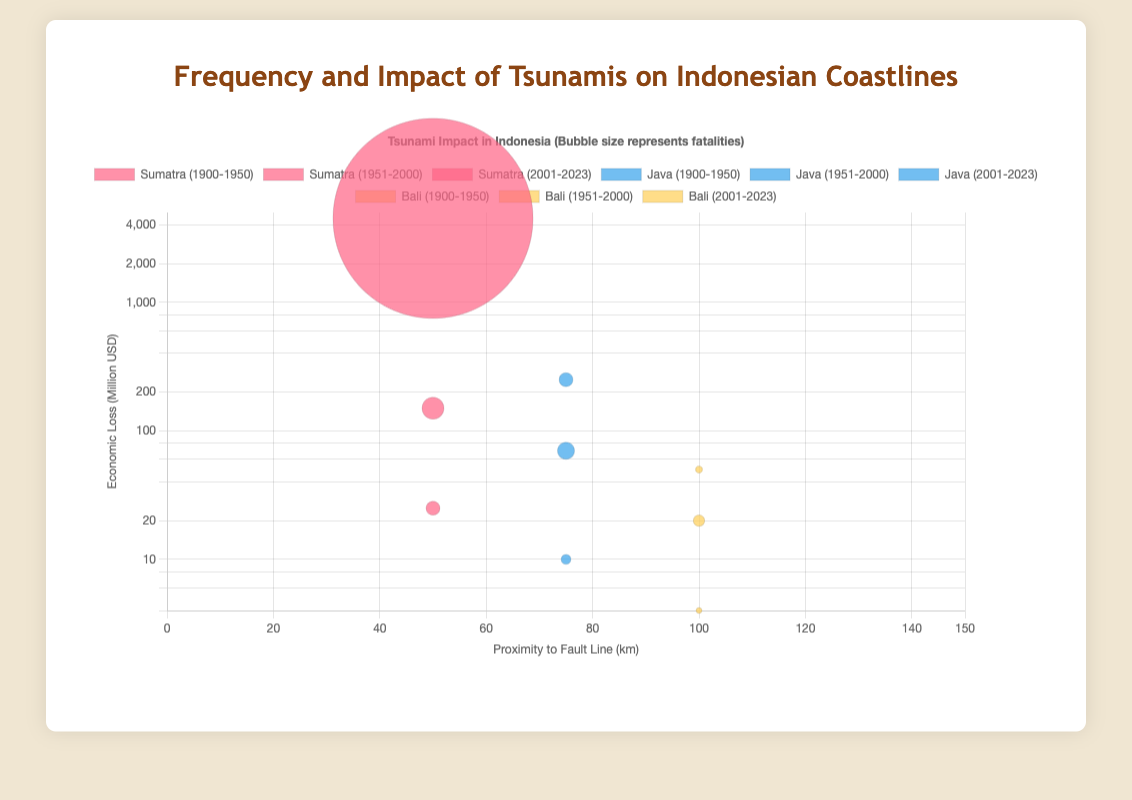What is the economic loss range that can be seen in this bubble chart? The y-axis represents economic loss in million USD, and the chart covers these values logarithmically. The minimum and maximum economic losses visible on the chart range from about $1 million to about $4500 million.
Answer: $1M to $4500M Which region had the highest fatalities in a single event, and during which time period? Observing the bubble size, Sumatra in the period 2001-2023 has the largest bubble, indicating the highest fatalities. This corresponds to the event with 250,000 fatalities.
Answer: Sumatra, 2001-2023 How does the proximity to fault lines impact economic losses for Java during the period 1951-2000? Java has a proximity of 75 km to the fault line in 1951-2000. The economic loss during this period is $70 million, as indicated by the y-coordinate of the bubble for Java in this period.
Answer: $70M at 75 km What is the average frequency of tsunamis in Sumatra across all time periods? Summing up the frequencies for Sumatra: 5 (1900-1950), 7 (1951-2000), and 3 (2001-2023) gives a total of 15. There are 3 time periods, so the average frequency is 15 / 3 = 5.
Answer: 5 Which region has the smallest bubble, and what does it represent? The smallest bubble appears in Bali for the period 1900-1950, representing 200 fatalities, as indicated by the smallest visual size among the bubbles.
Answer: Bali, 200 fatalities Compare the economic losses in Sumatra between the periods 1900-1950 and 2001-2023. Sumatra had economic losses of $25M in 1900-1950 and $4500M in 2001-2023. The increase from $25M to $4500M marks a significant growth, which can be observed as a large upward movement on the y-axis for the latter period.
Answer: $25M to $4500M Which region and time period shows a moderate level (not maximum nor minimum) of fatalities, and what is the value? Observing the bubble sizes, Java in the period 1951-2000 shows a moderate bubble size, representing 1800 fatalities.
Answer: Java, 1951-2000, 1800 fatalities What is the trend in the number of tsunamis in Java over the three time periods? In Java, the frequencies are as follows: 2 (1900-1950), 4 (1951-2000), and 2 (2001-2023). Thus, the trend shows an increase from 2 to 4 between the first two periods and then a decrease back to 2 in the last period.
Answer: Increase, then decrease What is the economic impact difference between Java and Bali for the period 2001-2023? Java had an economic loss of $250M while Bali had $50M in 2001-2023. The difference is $250M - $50M = $200M.
Answer: $200M 